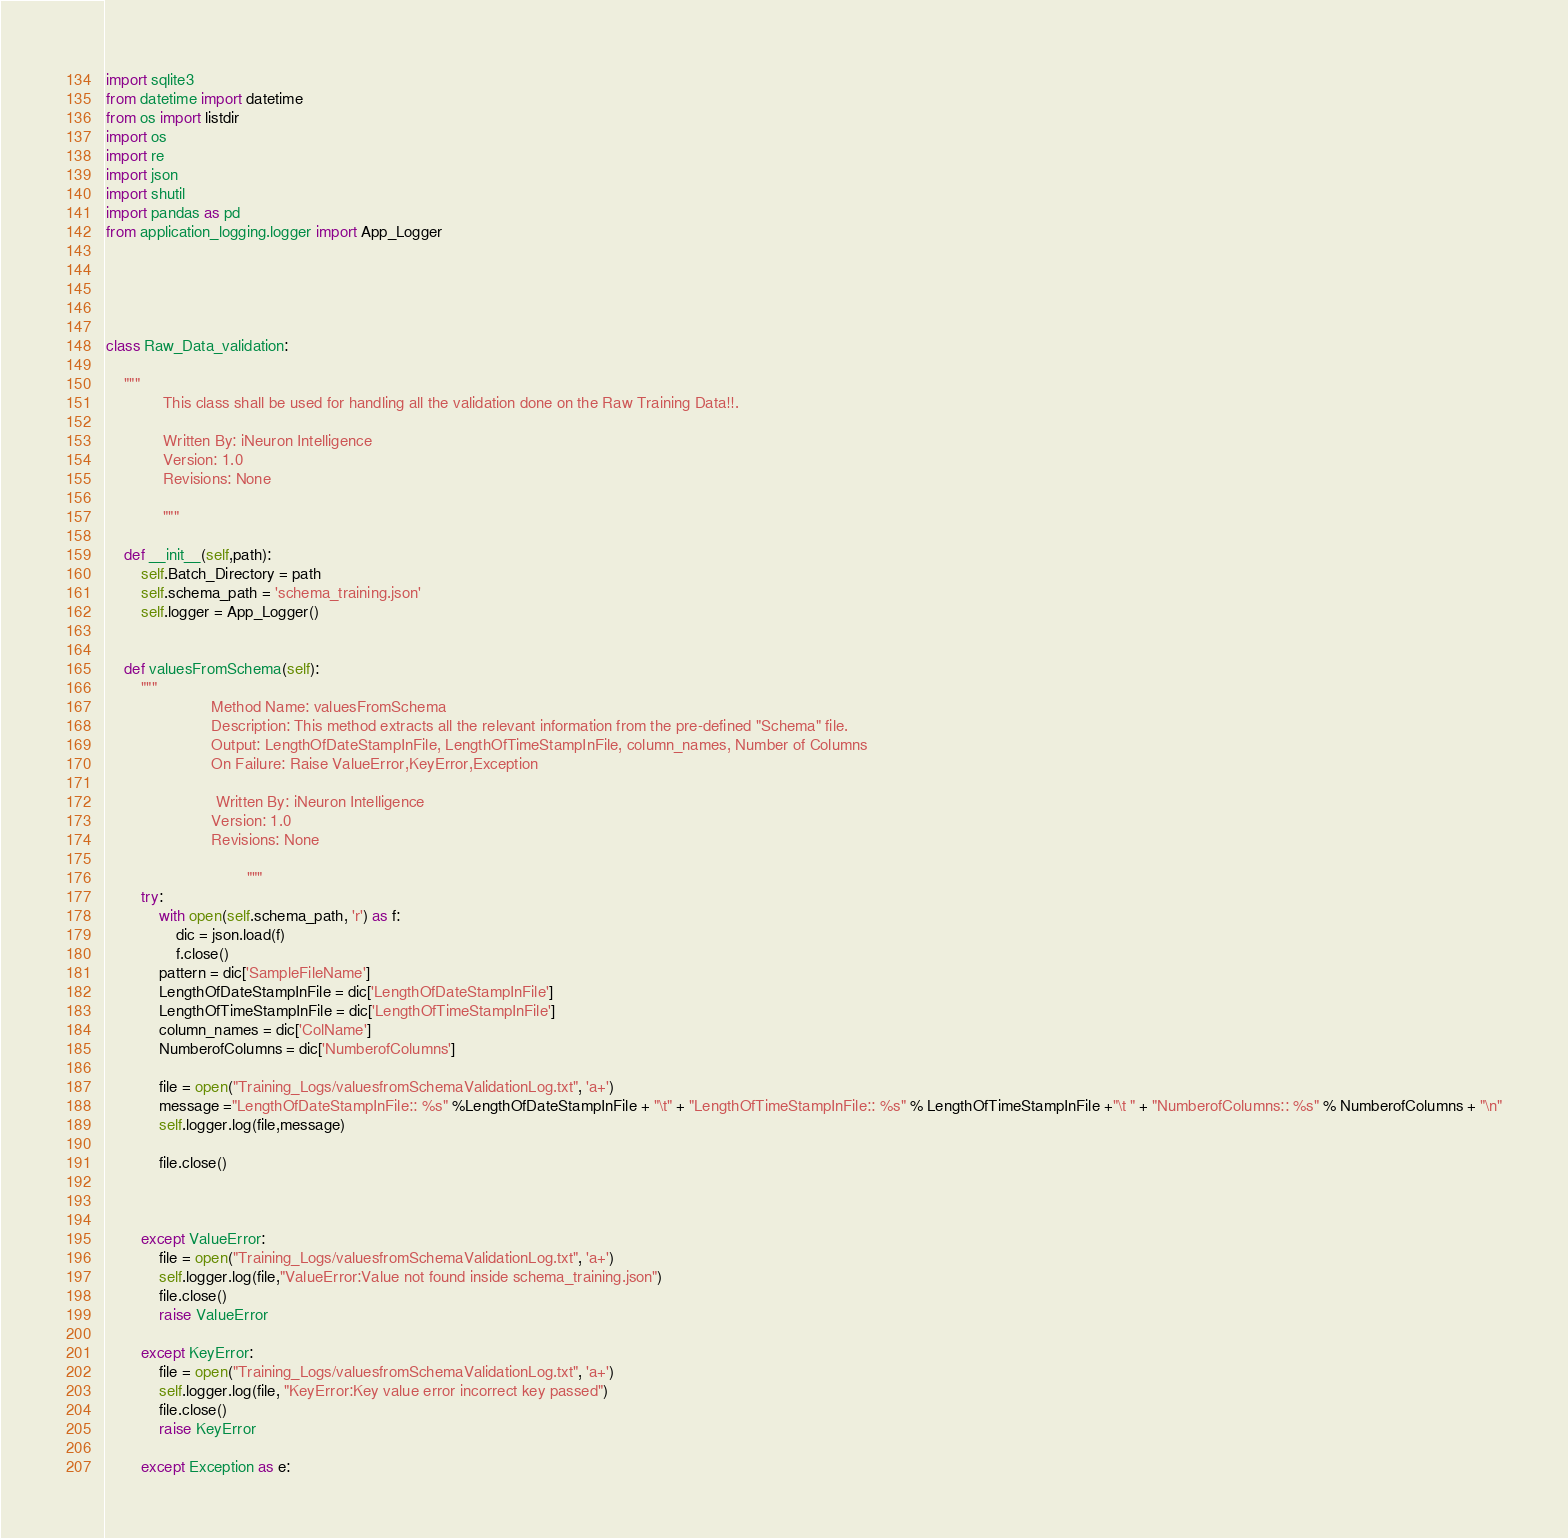Convert code to text. <code><loc_0><loc_0><loc_500><loc_500><_Python_>import sqlite3
from datetime import datetime
from os import listdir
import os
import re
import json
import shutil
import pandas as pd
from application_logging.logger import App_Logger





class Raw_Data_validation:

    """
             This class shall be used for handling all the validation done on the Raw Training Data!!.

             Written By: iNeuron Intelligence
             Version: 1.0
             Revisions: None

             """

    def __init__(self,path):
        self.Batch_Directory = path
        self.schema_path = 'schema_training.json'
        self.logger = App_Logger()


    def valuesFromSchema(self):
        """
                        Method Name: valuesFromSchema
                        Description: This method extracts all the relevant information from the pre-defined "Schema" file.
                        Output: LengthOfDateStampInFile, LengthOfTimeStampInFile, column_names, Number of Columns
                        On Failure: Raise ValueError,KeyError,Exception

                         Written By: iNeuron Intelligence
                        Version: 1.0
                        Revisions: None

                                """
        try:
            with open(self.schema_path, 'r') as f:
                dic = json.load(f)
                f.close()
            pattern = dic['SampleFileName']
            LengthOfDateStampInFile = dic['LengthOfDateStampInFile']
            LengthOfTimeStampInFile = dic['LengthOfTimeStampInFile']
            column_names = dic['ColName']
            NumberofColumns = dic['NumberofColumns']

            file = open("Training_Logs/valuesfromSchemaValidationLog.txt", 'a+')
            message ="LengthOfDateStampInFile:: %s" %LengthOfDateStampInFile + "\t" + "LengthOfTimeStampInFile:: %s" % LengthOfTimeStampInFile +"\t " + "NumberofColumns:: %s" % NumberofColumns + "\n"
            self.logger.log(file,message)

            file.close()



        except ValueError:
            file = open("Training_Logs/valuesfromSchemaValidationLog.txt", 'a+')
            self.logger.log(file,"ValueError:Value not found inside schema_training.json")
            file.close()
            raise ValueError

        except KeyError:
            file = open("Training_Logs/valuesfromSchemaValidationLog.txt", 'a+')
            self.logger.log(file, "KeyError:Key value error incorrect key passed")
            file.close()
            raise KeyError

        except Exception as e:</code> 